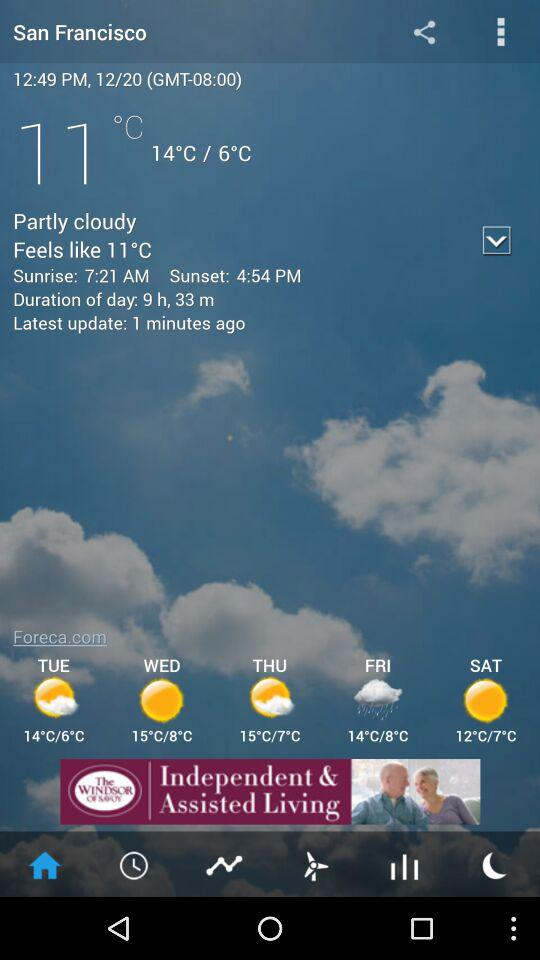How many degrees warmer is the high temperature than the low temperature?
Answer the question using a single word or phrase. 8 